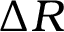<formula> <loc_0><loc_0><loc_500><loc_500>\Delta R</formula> 